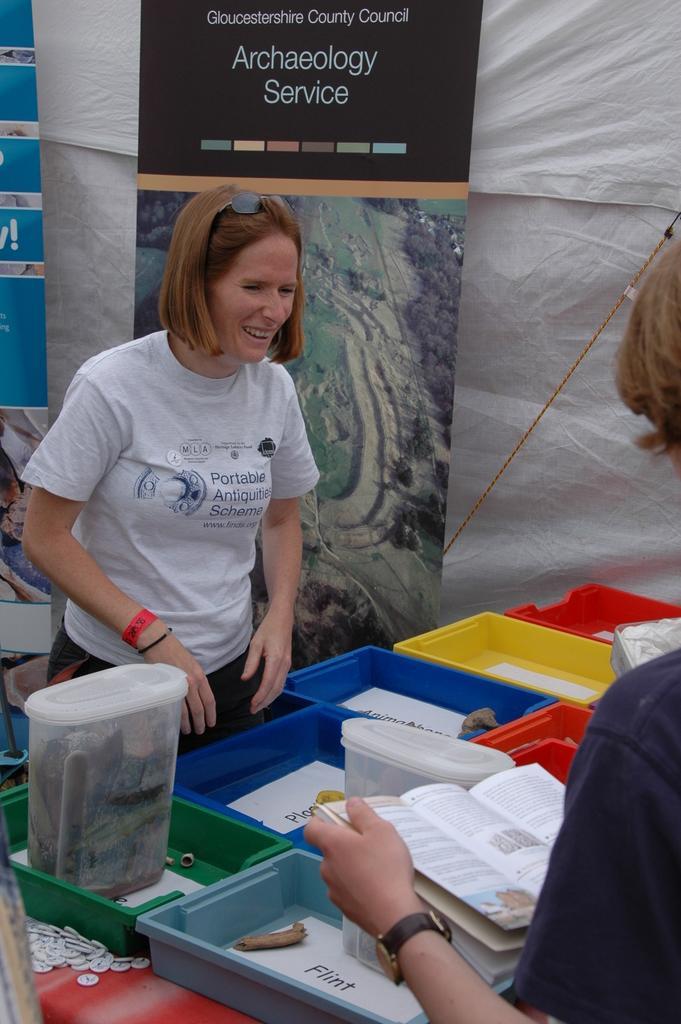Can you describe this image briefly? In the image there is a woman, she is holding a book in her hand and in front of the women there are colorful boxes kept on the table and in each box there is some paper with text and on the other side of the table there is another woman, behind her there are two banners. 